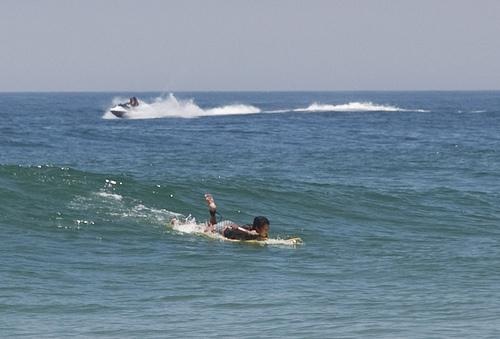How many times does the jet ski appear in the image, and is there any additional information about it? The jet ski appears twice in the image, both times in the background, moving at high speed on the water. Identify the primary activity happening in the picture and the primary individual participating in it. The primary activity in the image is surfing, with a person paddling on a surfboard in the foreground. Give an emotional response one might feel while looking at this picture. One might feel a sense of adventure and excitement while looking at this beach scene with people surfing and jet skiing. Describe the different ways the person on the surfboard was referred to in the image. The person on the surfboard is referred to as a "person paddling on a surfboard." 